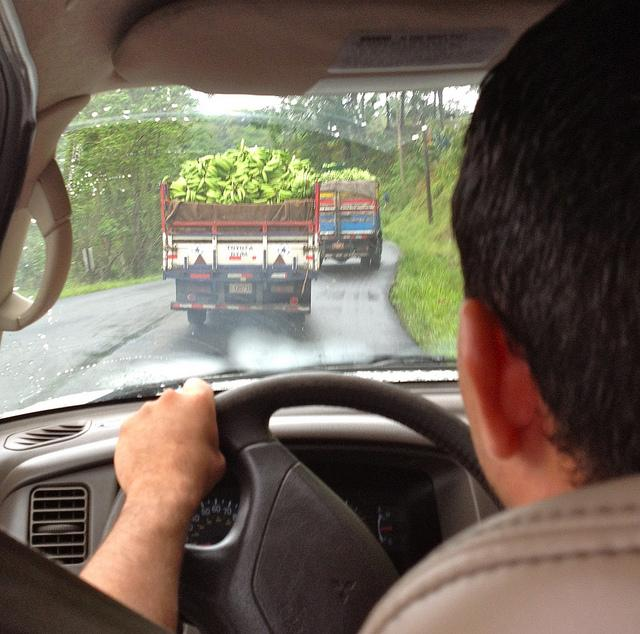What are the chances that at least one banana will fall out of the truck? high 